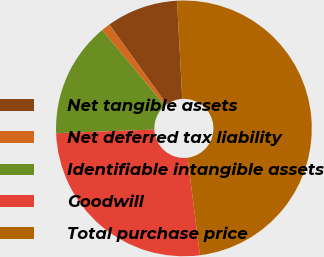Convert chart. <chart><loc_0><loc_0><loc_500><loc_500><pie_chart><fcel>Net tangible assets<fcel>Net deferred tax liability<fcel>Identifiable intangible assets<fcel>Goodwill<fcel>Total purchase price<nl><fcel>9.05%<fcel>1.14%<fcel>14.56%<fcel>26.4%<fcel>48.86%<nl></chart> 